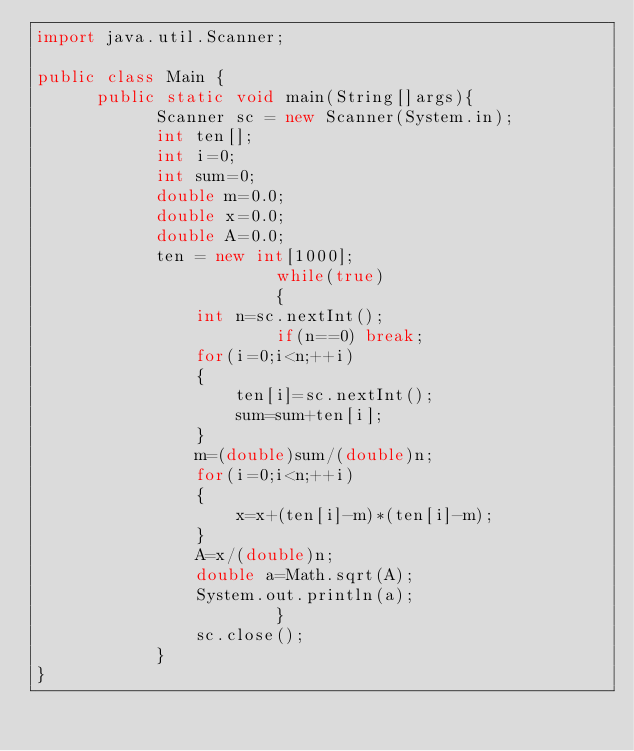<code> <loc_0><loc_0><loc_500><loc_500><_Java_>import java.util.Scanner;

public class Main {
	  public static void main(String[]args){
		    Scanner sc = new Scanner(System.in);
		    int ten[];
		    int i=0;
		    int sum=0;
		    double m=0.0;
		    double x=0.0;
		    double A=0.0;
		    ten = new int[1000];
                        while(true)
                        {
		    	int n=sc.nextInt();
                        if(n==0) break;
		    	for(i=0;i<n;++i)
		    	{
		    		ten[i]=sc.nextInt();
		    		sum=sum+ten[i];
		    	}
		    	m=(double)sum/(double)n;
		    	for(i=0;i<n;++i)
		    	{
		    		x=x+(ten[i]-m)*(ten[i]-m);
		    	}
		    	A=x/(double)n;
		    	double a=Math.sqrt(A);
		    	System.out.println(a);
                        }
		    	sc.close();
		    }
}

</code> 